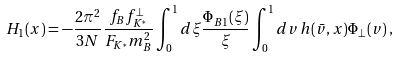<formula> <loc_0><loc_0><loc_500><loc_500>H _ { 1 } ( x ) = - \frac { 2 \pi ^ { 2 } } { 3 N } \frac { f _ { B } f ^ { \perp } _ { K ^ { * } } } { F _ { K ^ { * } } m ^ { 2 } _ { B } } \int ^ { 1 } _ { 0 } d \xi \frac { \Phi _ { B 1 } ( \xi ) } { \xi } \int ^ { 1 } _ { 0 } d v \, h ( \bar { v } , x ) \Phi _ { \perp } ( v ) \, ,</formula> 